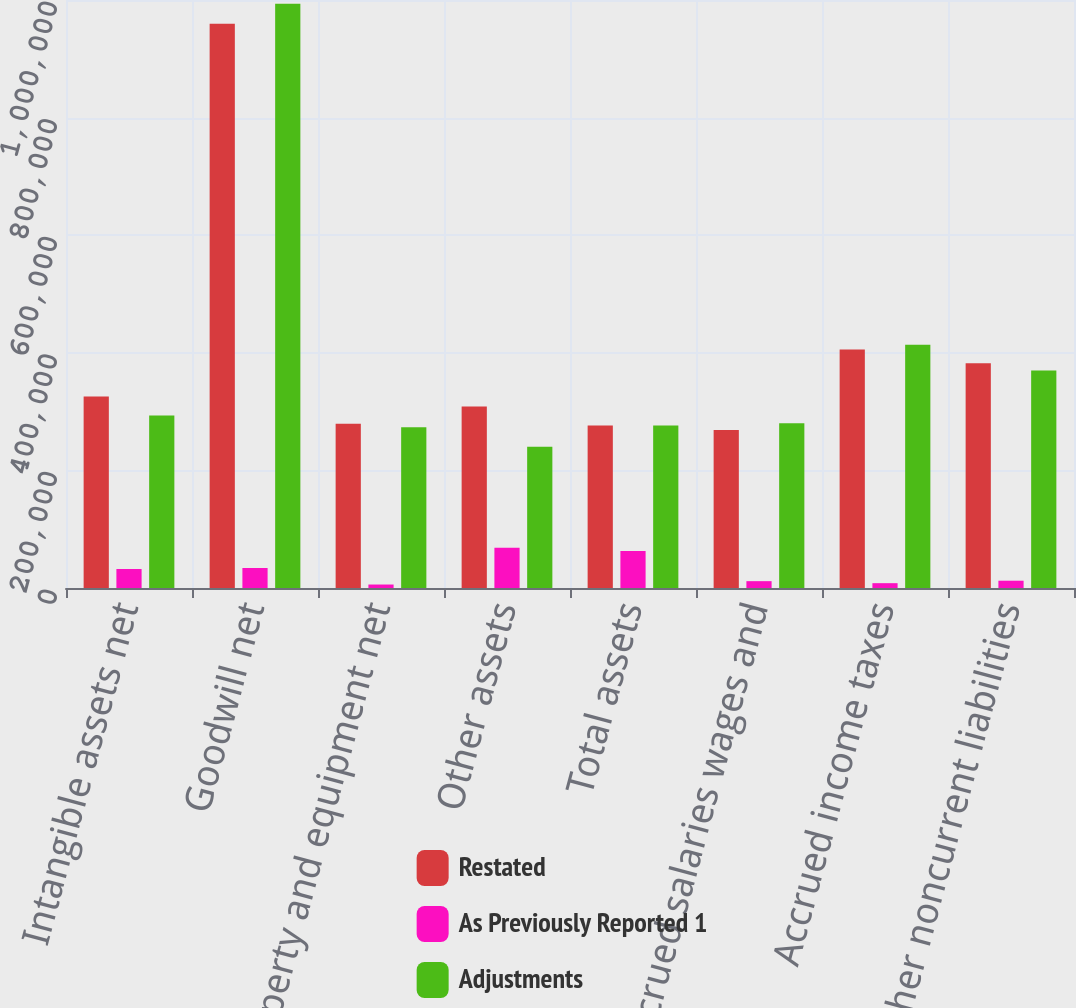Convert chart. <chart><loc_0><loc_0><loc_500><loc_500><stacked_bar_chart><ecel><fcel>Intangible assets net<fcel>Goodwill net<fcel>Property and equipment net<fcel>Other assets<fcel>Total assets<fcel>Accrued salaries wages and<fcel>Accrued income taxes<fcel>Other noncurrent liabilities<nl><fcel>Restated<fcel>325829<fcel>959418<fcel>279220<fcel>308714<fcel>276262<fcel>268747<fcel>405668<fcel>382168<nl><fcel>As Previously Reported 1<fcel>32352<fcel>34049<fcel>5917<fcel>68333<fcel>62736<fcel>11620<fcel>8200<fcel>12399<nl><fcel>Adjustments<fcel>293477<fcel>993467<fcel>273303<fcel>240381<fcel>276262<fcel>280367<fcel>413868<fcel>369769<nl></chart> 